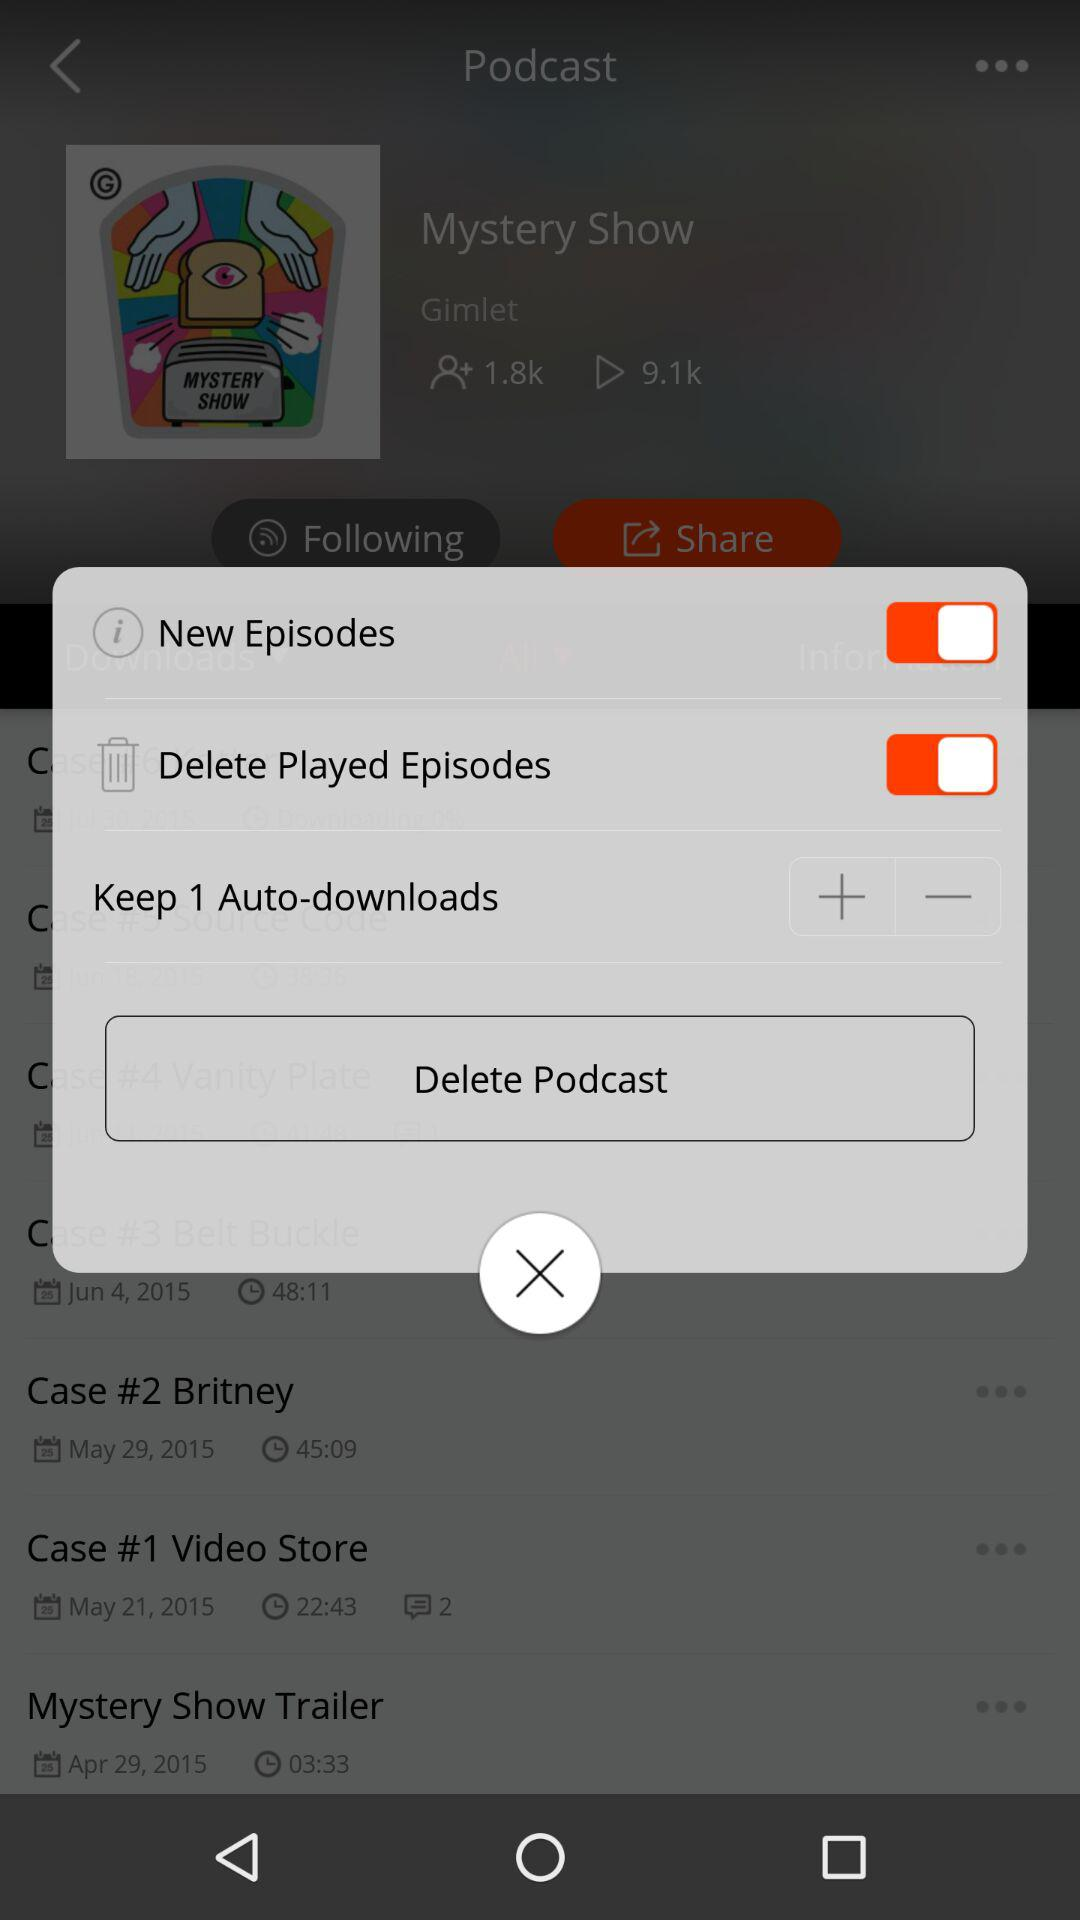What is the status of "New Episodes"? The status is "on". 